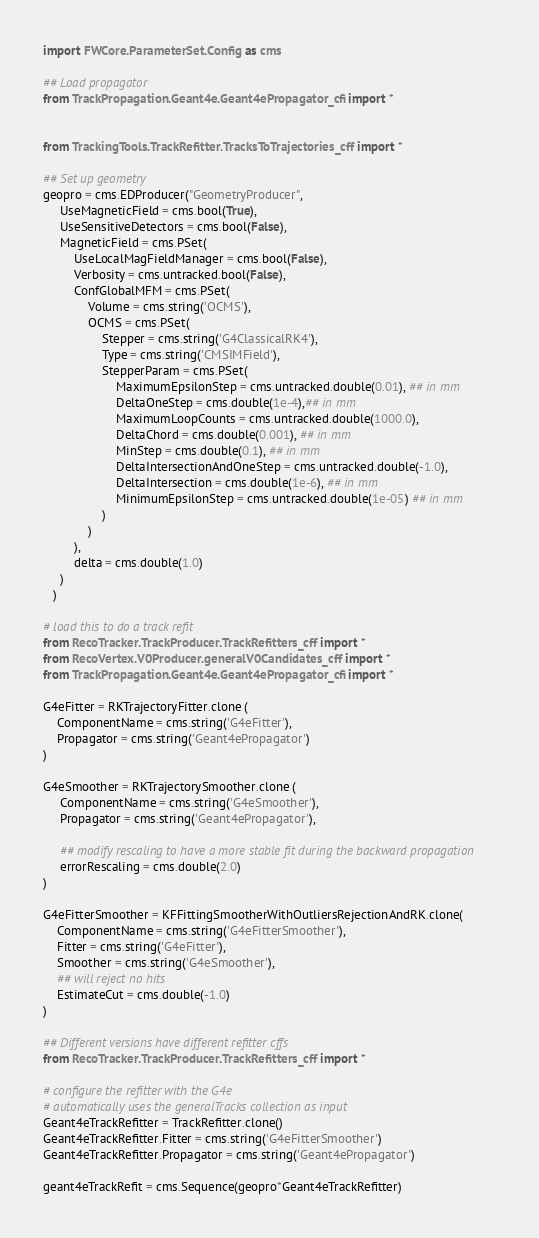<code> <loc_0><loc_0><loc_500><loc_500><_Python_>import FWCore.ParameterSet.Config as cms

## Load propagator
from TrackPropagation.Geant4e.Geant4ePropagator_cfi import *


from TrackingTools.TrackRefitter.TracksToTrajectories_cff import *

## Set up geometry
geopro = cms.EDProducer("GeometryProducer",
     UseMagneticField = cms.bool(True),
     UseSensitiveDetectors = cms.bool(False),
     MagneticField = cms.PSet(
         UseLocalMagFieldManager = cms.bool(False),
         Verbosity = cms.untracked.bool(False),
         ConfGlobalMFM = cms.PSet(
             Volume = cms.string('OCMS'),
             OCMS = cms.PSet(
                 Stepper = cms.string('G4ClassicalRK4'),
                 Type = cms.string('CMSIMField'),
                 StepperParam = cms.PSet(
                     MaximumEpsilonStep = cms.untracked.double(0.01), ## in mm
                     DeltaOneStep = cms.double(1e-4),## in mm
                     MaximumLoopCounts = cms.untracked.double(1000.0),
                     DeltaChord = cms.double(0.001), ## in mm
                     MinStep = cms.double(0.1), ## in mm
                     DeltaIntersectionAndOneStep = cms.untracked.double(-1.0),
                     DeltaIntersection = cms.double(1e-6), ## in mm
                     MinimumEpsilonStep = cms.untracked.double(1e-05) ## in mm
                 )
             )
         ),
         delta = cms.double(1.0)
     )
   )

# load this to do a track refit
from RecoTracker.TrackProducer.TrackRefitters_cff import *
from RecoVertex.V0Producer.generalV0Candidates_cff import *
from TrackPropagation.Geant4e.Geant4ePropagator_cfi import *

G4eFitter = RKTrajectoryFitter.clone ( 
    ComponentName = cms.string('G4eFitter'),
    Propagator = cms.string('Geant4ePropagator') 
)

G4eSmoother = RKTrajectorySmoother.clone (
     ComponentName = cms.string('G4eSmoother'),
     Propagator = cms.string('Geant4ePropagator'),
 
     ## modify rescaling to have a more stable fit during the backward propagation
     errorRescaling = cms.double(2.0)
)

G4eFitterSmoother = KFFittingSmootherWithOutliersRejectionAndRK.clone(
    ComponentName = cms.string('G4eFitterSmoother'),
    Fitter = cms.string('G4eFitter'),
    Smoother = cms.string('G4eSmoother'),
    ## will reject no hits
    EstimateCut = cms.double(-1.0)
)

## Different versions have different refitter cffs
from RecoTracker.TrackProducer.TrackRefitters_cff import *

# configure the refitter with the G4e
# automatically uses the generalTracks collection as input
Geant4eTrackRefitter = TrackRefitter.clone()
Geant4eTrackRefitter.Fitter = cms.string('G4eFitterSmoother')
Geant4eTrackRefitter.Propagator = cms.string('Geant4ePropagator')

geant4eTrackRefit = cms.Sequence(geopro*Geant4eTrackRefitter)
</code> 